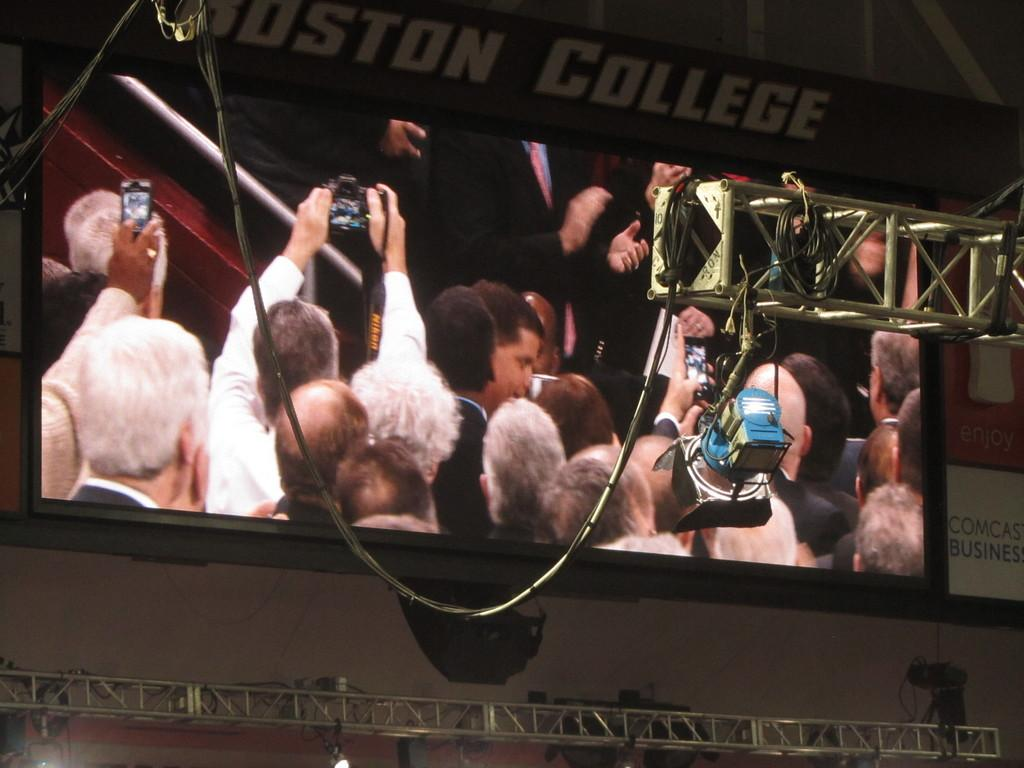What is the main object in the image? There is a screen in the image. What are the people in the image holding? The people in the image are holding a smartphone and a camera. What can be seen in the background of the image? There are people wearing blazers in the background of the image. What are these people in the background doing? These people in the background are clapping their hands. What type of mist can be seen surrounding the people in the image? There is no mist present in the image; it features a screen, people holding devices, and people in the background clapping their hands. Can you tell me how many bats are flying around the people in the image? There are no bats present in the image. 